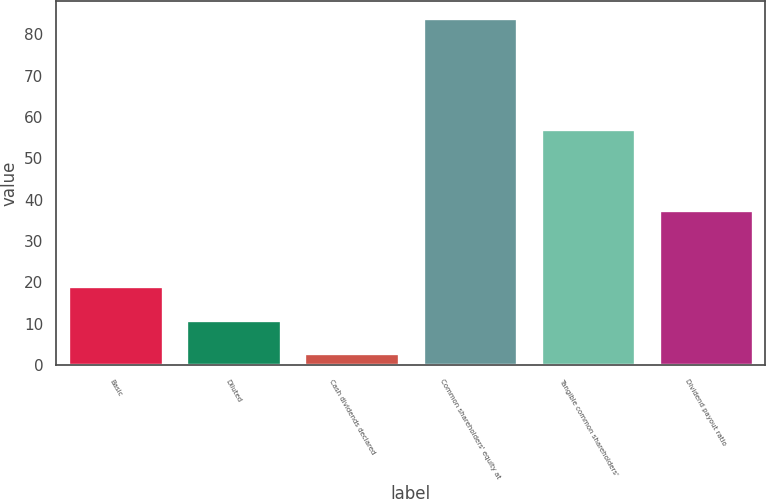<chart> <loc_0><loc_0><loc_500><loc_500><bar_chart><fcel>Basic<fcel>Diluted<fcel>Cash dividends declared<fcel>Common shareholders' equity at<fcel>Tangible common shareholders'<fcel>Dividend payout ratio<nl><fcel>19.02<fcel>10.91<fcel>2.8<fcel>83.88<fcel>57.06<fcel>37.49<nl></chart> 